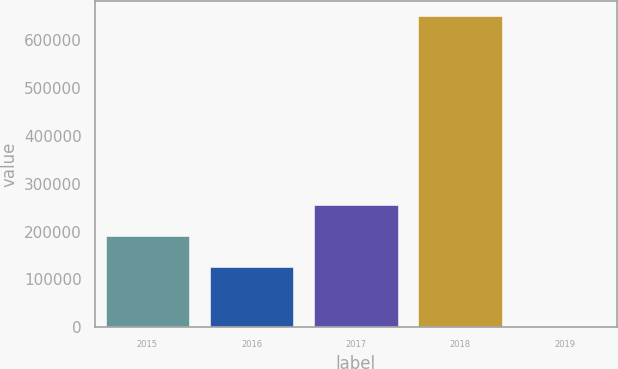Convert chart to OTSL. <chart><loc_0><loc_0><loc_500><loc_500><bar_chart><fcel>2015<fcel>2016<fcel>2017<fcel>2018<fcel>2019<nl><fcel>190131<fcel>125131<fcel>255131<fcel>650022<fcel>23<nl></chart> 